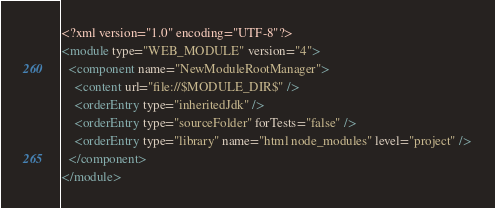<code> <loc_0><loc_0><loc_500><loc_500><_XML_><?xml version="1.0" encoding="UTF-8"?>
<module type="WEB_MODULE" version="4">
  <component name="NewModuleRootManager">
    <content url="file://$MODULE_DIR$" />
    <orderEntry type="inheritedJdk" />
    <orderEntry type="sourceFolder" forTests="false" />
    <orderEntry type="library" name="html node_modules" level="project" />
  </component>
</module></code> 